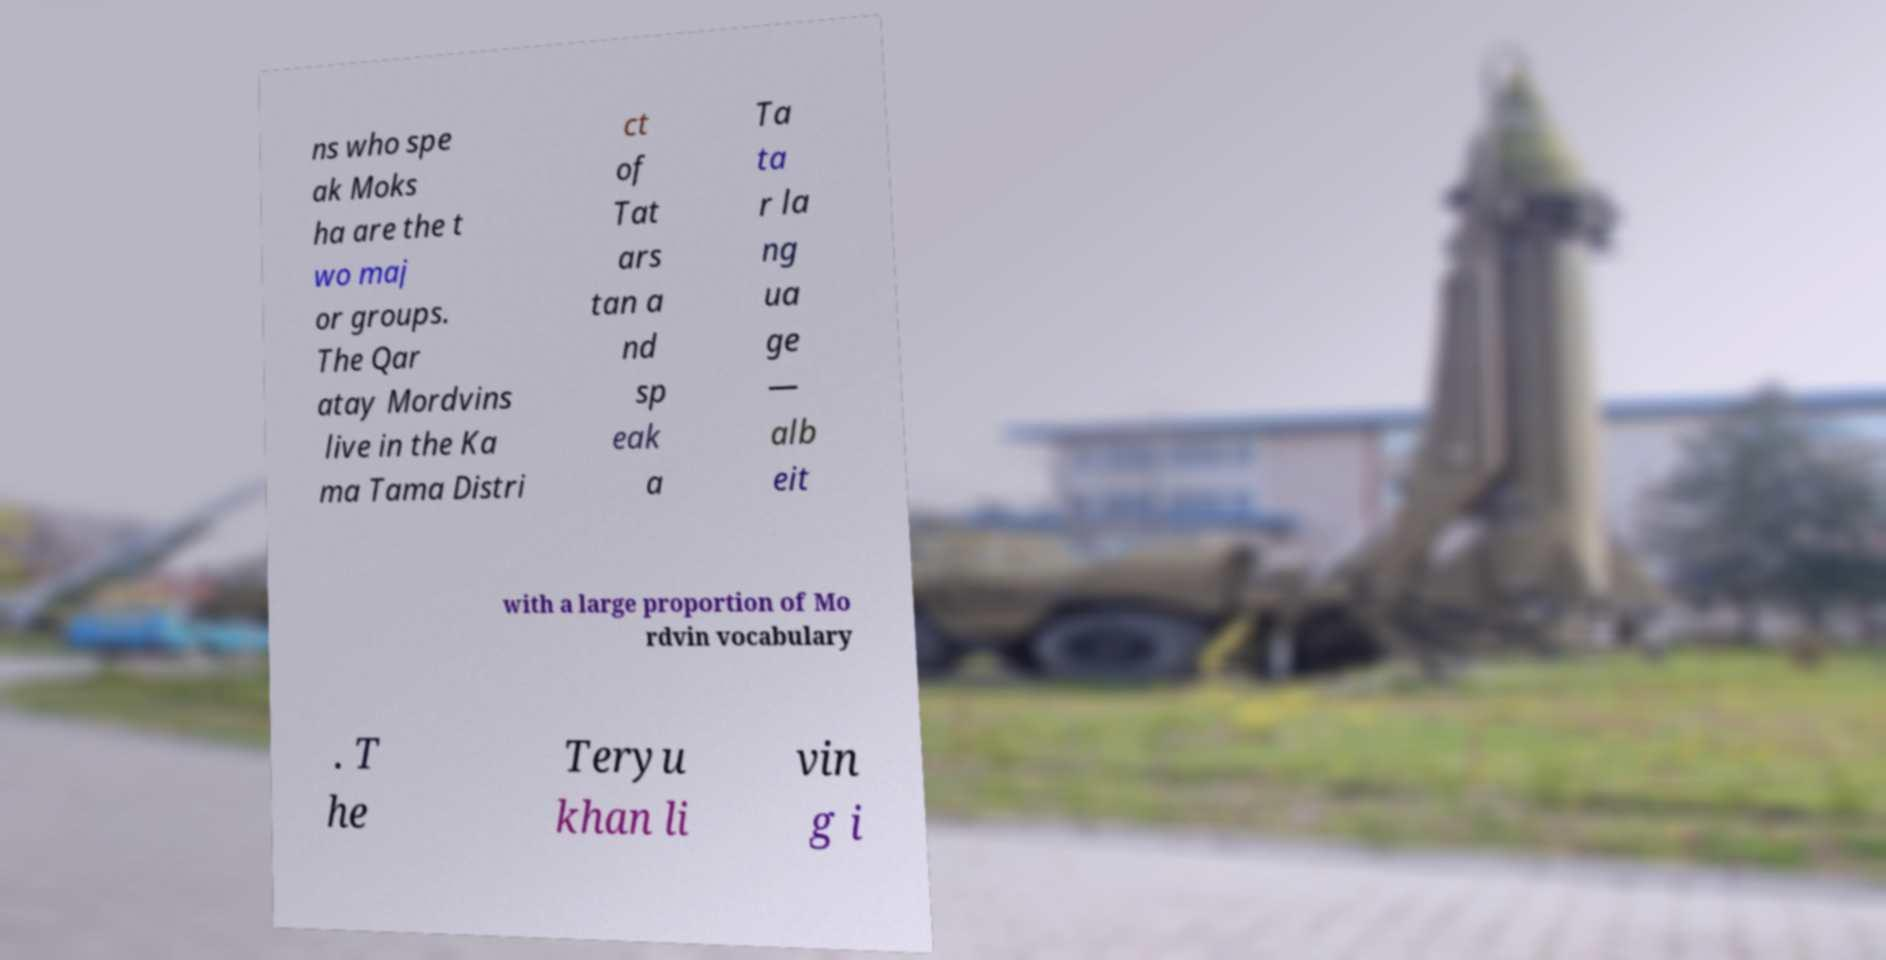Can you accurately transcribe the text from the provided image for me? ns who spe ak Moks ha are the t wo maj or groups. The Qar atay Mordvins live in the Ka ma Tama Distri ct of Tat ars tan a nd sp eak a Ta ta r la ng ua ge — alb eit with a large proportion of Mo rdvin vocabulary . T he Teryu khan li vin g i 